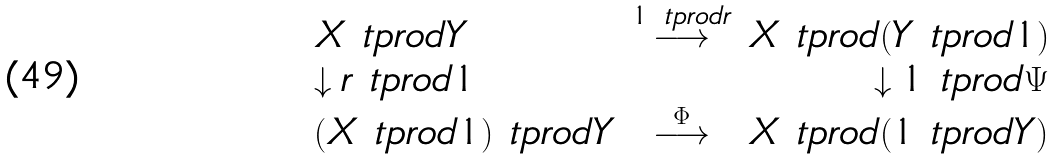<formula> <loc_0><loc_0><loc_500><loc_500>\begin{array} { l c r } X \ t p r o d Y & \stackrel { 1 \ t p r o d r } { \longrightarrow } & X \ t p r o d ( Y \ t p r o d 1 ) \\ \downarrow r \ t p r o d 1 & & \downarrow 1 \ t p r o d \Psi \\ ( X \ t p r o d 1 ) \ t p r o d Y & \stackrel { \Phi } { \longrightarrow } & X \ t p r o d ( 1 \ t p r o d Y ) \end{array}</formula> 